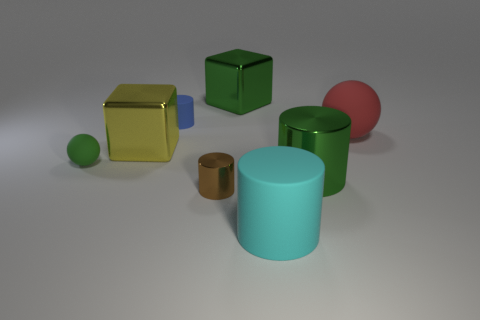Subtract all green balls. How many balls are left? 1 Subtract 0 yellow cylinders. How many objects are left? 8 Subtract all cubes. How many objects are left? 6 Subtract 2 cubes. How many cubes are left? 0 Subtract all purple spheres. Subtract all brown cylinders. How many spheres are left? 2 Subtract all blue cubes. How many blue cylinders are left? 1 Subtract all spheres. Subtract all big yellow metal blocks. How many objects are left? 5 Add 1 tiny brown metallic cylinders. How many tiny brown metallic cylinders are left? 2 Add 4 large brown cylinders. How many large brown cylinders exist? 4 Add 1 green cubes. How many objects exist? 9 